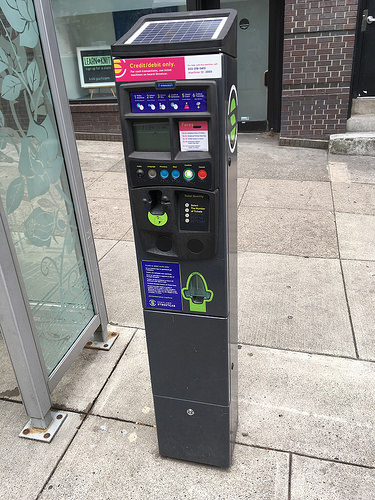<image>
Is there a meter behind the buttons? Yes. From this viewpoint, the meter is positioned behind the buttons, with the buttons partially or fully occluding the meter. 